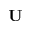Convert formula to latex. <formula><loc_0><loc_0><loc_500><loc_500>U</formula> 